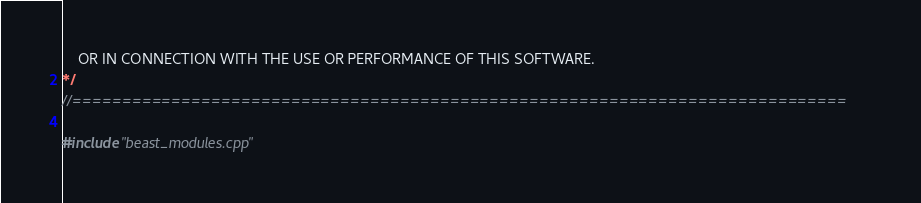<code> <loc_0><loc_0><loc_500><loc_500><_ObjectiveC_>	OR IN CONNECTION WITH THE USE OR PERFORMANCE OF THIS SOFTWARE.
*/
//==============================================================================

#include "beast_modules.cpp"
</code> 